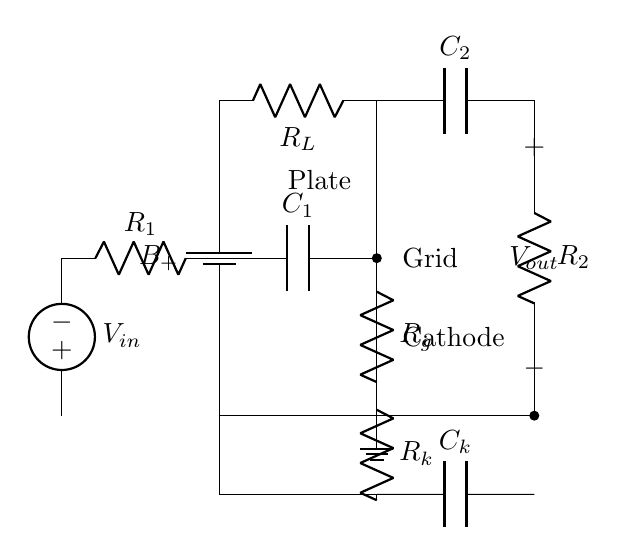What is the purpose of the component labeled R1? R1 is a resistor connected in series with the input voltage source V_in, and it is typically used to limit the current entering the grid of the vacuum tube.
Answer: Resistor What type of vacuum tube is used in the circuit? The circuit diagram specifically shows a triode, which is a type of vacuum tube commonly used for amplification due to its three electrodes.
Answer: Triode What does the label C1 represent in the circuit? C1 is a capacitor that is connected to the grid of the vacuum tube, which allows AC signals to pass while blocking DC components, thus aiding in the amplification process.
Answer: Capacitor What are the two main outputs in this amplifier circuit? The amplifier circuit has two main outputs: the plate output from the triode and the output after the capacitor C2, which is labeled as V_out.
Answer: Plate output and V_out How does the resistor Rk affect the circuit? Rk is connected to the cathode of the triode and plays a crucial role in determining the biasing conditions of the tube, affecting its gain and linearity in amplification.
Answer: Biasing What is the relationship between C1 and Rg in terms of frequency response? C1 and Rg together form a high-pass filter, which allows higher frequency signals to pass through while attenuating lower frequency signals, thus shaping the frequency response of the amplifier.
Answer: High-pass filter What is the function of Ck in the amplifier circuit? Ck is a coupling capacitor that connects the cathode of the triode to ground, allowing AC signals to pass while blocking DC, which stabilizes the operating point of the tube.
Answer: Coupling capacitor 